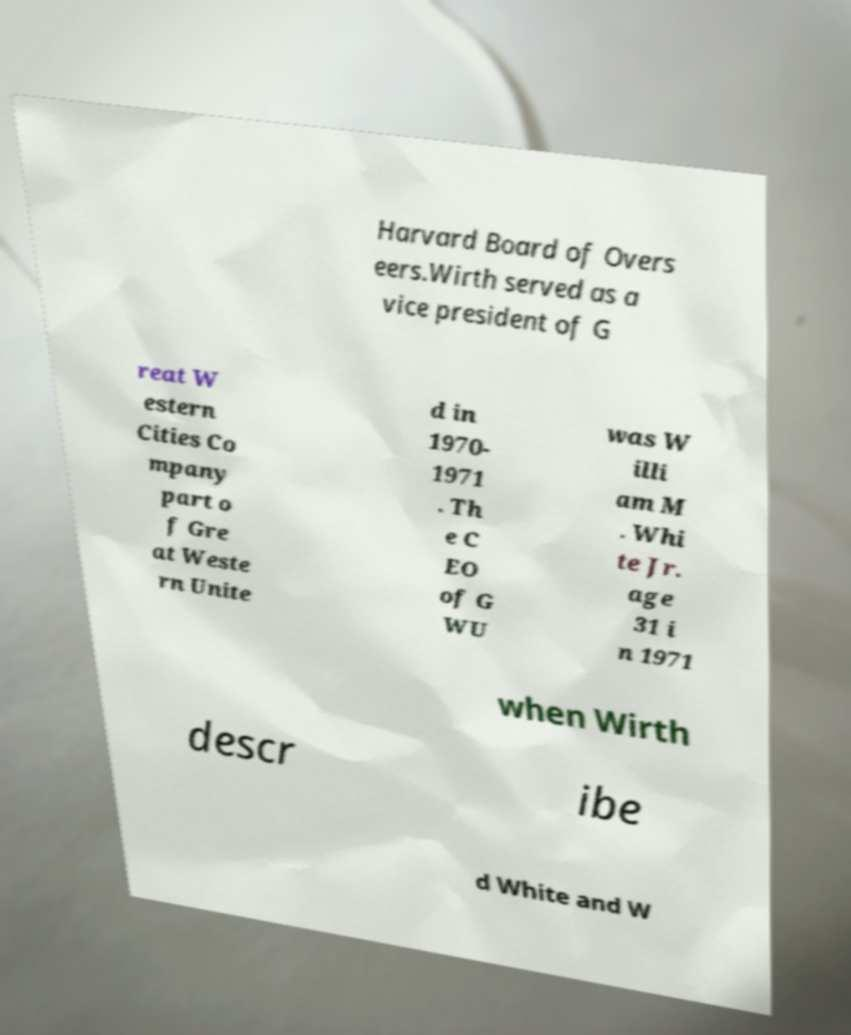What messages or text are displayed in this image? I need them in a readable, typed format. Harvard Board of Overs eers.Wirth served as a vice president of G reat W estern Cities Co mpany part o f Gre at Weste rn Unite d in 1970- 1971 . Th e C EO of G WU was W illi am M . Whi te Jr. age 31 i n 1971 when Wirth descr ibe d White and W 